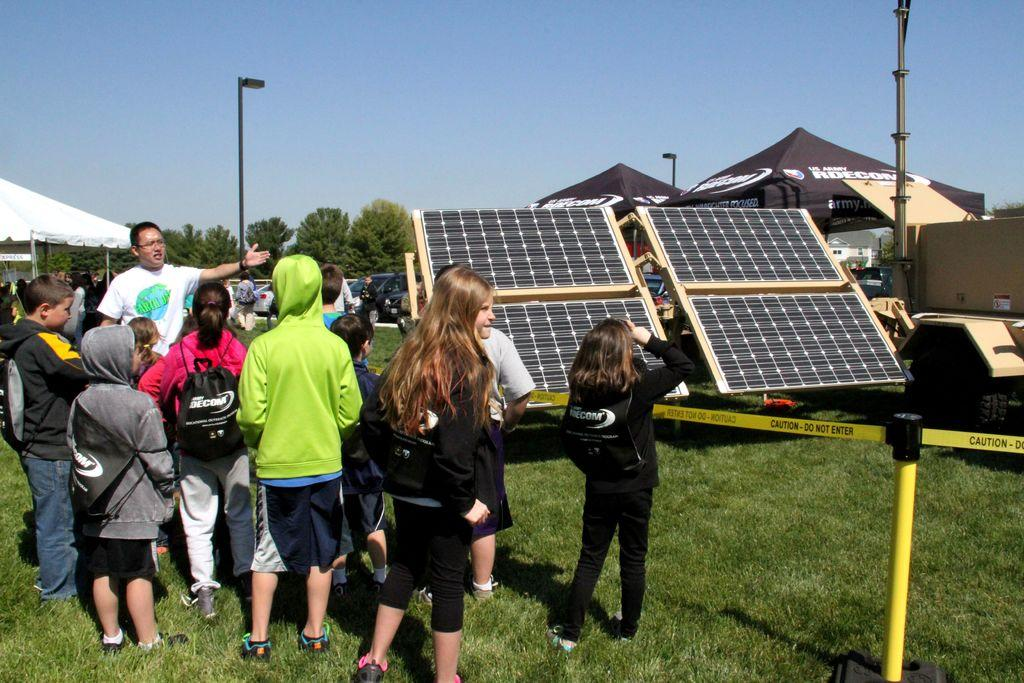How many people can be seen in the image? There are people in the image, but the exact number is not specified. What type of temporary shelters are present in the image? There are tents in the image. What is a source of renewable energy visible in the image? Solar panels are visible in the image. What type of ground surface is present at the bottom of the image? There is grass at the bottom of the image. What type of transportation is present in the image? There is a vehicle in the image. What type of support structures are present in the image? There are poles in the image. What type of natural vegetation is present in the image? There are trees in the image. What part of the natural environment is visible in the image? The sky is visible in the image. How many cars are visible in the image? There are cars in the image, but the exact number is not specified. What is the rate of the clock in the image? There is no clock present in the image, so it is not possible to determine the rate. What type of farming equipment is attached to the yoke in the image? There is no yoke or farming equipment present in the image. 